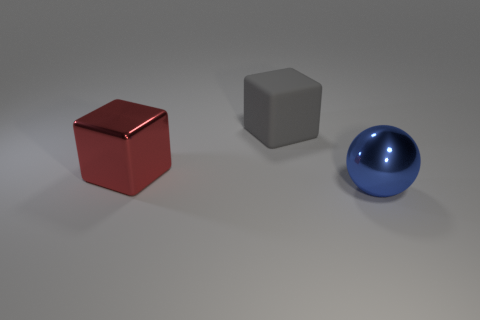Add 2 small blue spheres. How many objects exist? 5 Subtract all blocks. How many objects are left? 1 Add 2 large spheres. How many large spheres are left? 3 Add 1 gray rubber blocks. How many gray rubber blocks exist? 2 Subtract 0 gray balls. How many objects are left? 3 Subtract all gray spheres. Subtract all green blocks. How many spheres are left? 1 Subtract all large green shiny cubes. Subtract all matte things. How many objects are left? 2 